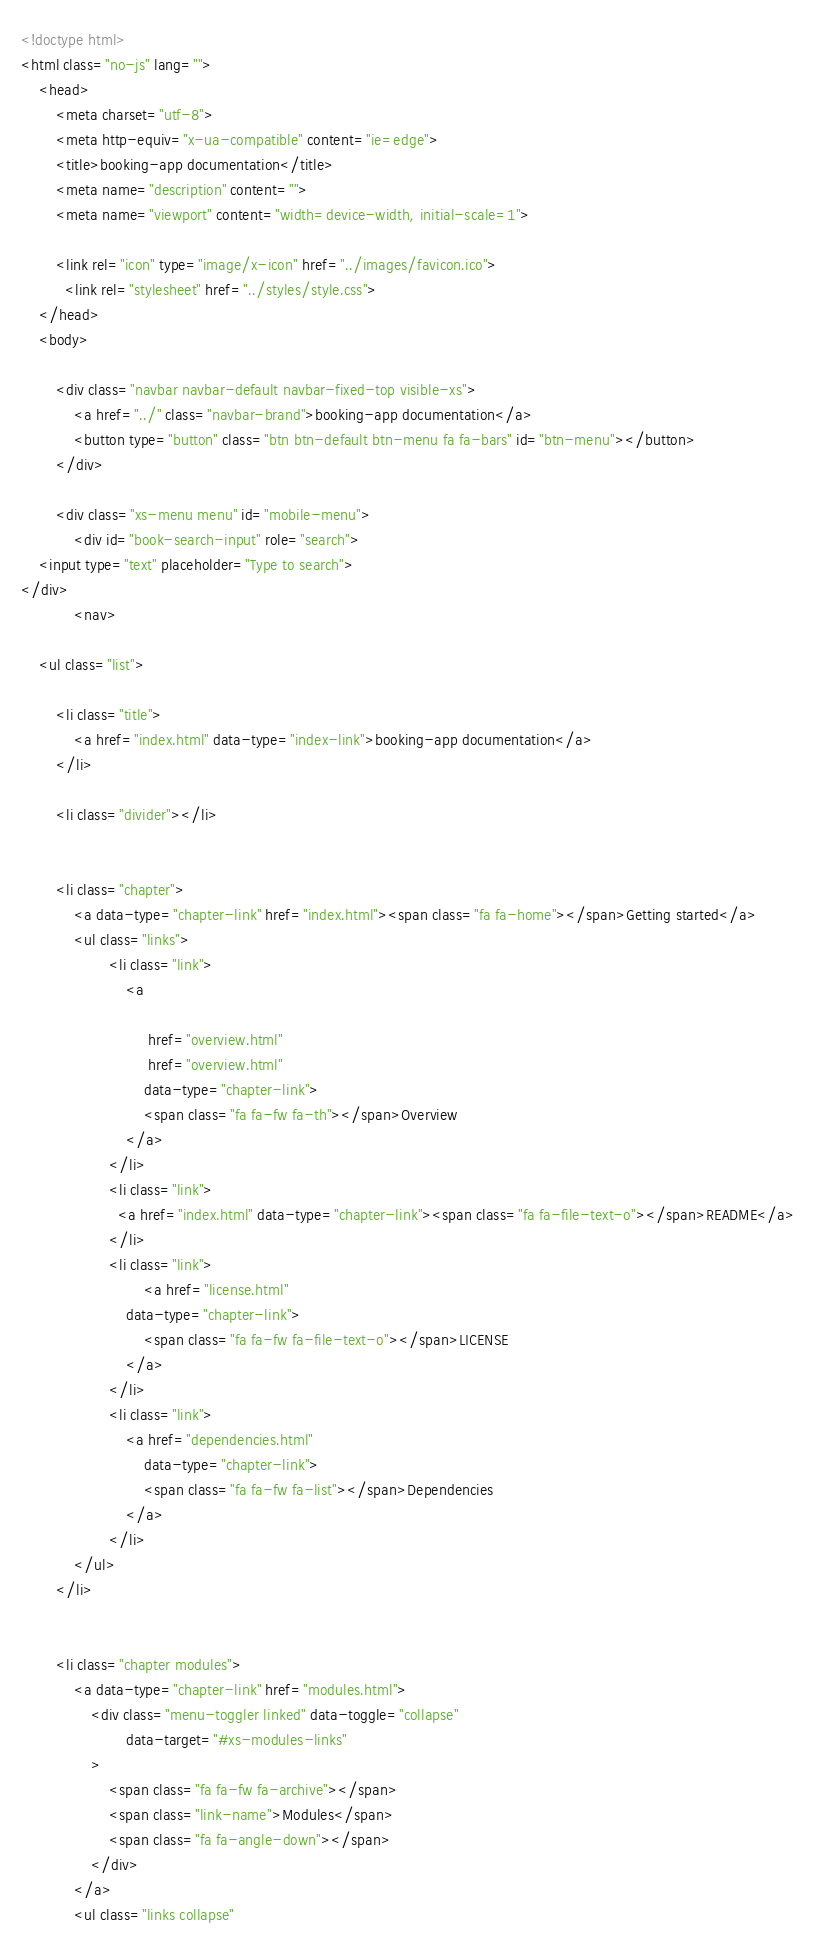<code> <loc_0><loc_0><loc_500><loc_500><_HTML_><!doctype html>
<html class="no-js" lang="">
    <head>
        <meta charset="utf-8">
        <meta http-equiv="x-ua-compatible" content="ie=edge">
        <title>booking-app documentation</title>
        <meta name="description" content="">
        <meta name="viewport" content="width=device-width, initial-scale=1">

        <link rel="icon" type="image/x-icon" href="../images/favicon.ico">
	      <link rel="stylesheet" href="../styles/style.css">
    </head>
    <body>

        <div class="navbar navbar-default navbar-fixed-top visible-xs">
            <a href="../" class="navbar-brand">booking-app documentation</a>
            <button type="button" class="btn btn-default btn-menu fa fa-bars" id="btn-menu"></button>
        </div>

        <div class="xs-menu menu" id="mobile-menu">
            <div id="book-search-input" role="search">
    <input type="text" placeholder="Type to search">
</div>
            <nav>

    <ul class="list">

        <li class="title">
            <a href="index.html" data-type="index-link">booking-app documentation</a>
        </li>

        <li class="divider"></li>


        <li class="chapter">
            <a data-type="chapter-link" href="index.html"><span class="fa fa-home"></span>Getting started</a>
            <ul class="links">
                    <li class="link">
                        <a 
                            
                             href="overview.html" 
                             href="overview.html" 
                            data-type="chapter-link">
                            <span class="fa fa-fw fa-th"></span>Overview
                        </a>
                    </li>
                    <li class="link">
                      <a href="index.html" data-type="chapter-link"><span class="fa fa-file-text-o"></span>README</a>
                    </li>
                    <li class="link">
                            <a href="license.html"
                        data-type="chapter-link">
                            <span class="fa fa-fw fa-file-text-o"></span>LICENSE
                        </a>
                    </li>
                    <li class="link">
                        <a href="dependencies.html"
                            data-type="chapter-link">
                            <span class="fa fa-fw fa-list"></span>Dependencies
                        </a>
                    </li>
            </ul>
        </li>


        <li class="chapter modules">
            <a data-type="chapter-link" href="modules.html">
                <div class="menu-toggler linked" data-toggle="collapse"
                        data-target="#xs-modules-links"
                >
                    <span class="fa fa-fw fa-archive"></span>
                    <span class="link-name">Modules</span>
                    <span class="fa fa-angle-down"></span>
                </div>
            </a>
            <ul class="links collapse"</code> 